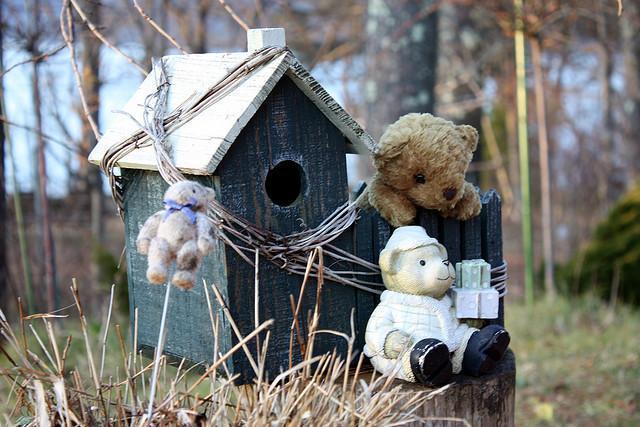How many teddy bears are in the picture?
Give a very brief answer. 3. How many teddy bears are in the photo?
Give a very brief answer. 3. 